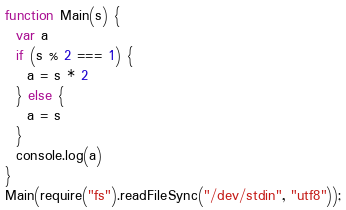<code> <loc_0><loc_0><loc_500><loc_500><_JavaScript_>function Main(s) {
  var a
  if (s % 2 === 1) {
    a = s * 2
  } else {
    a = s
  }
  console.log(a)
}
Main(require("fs").readFileSync("/dev/stdin", "utf8"));</code> 